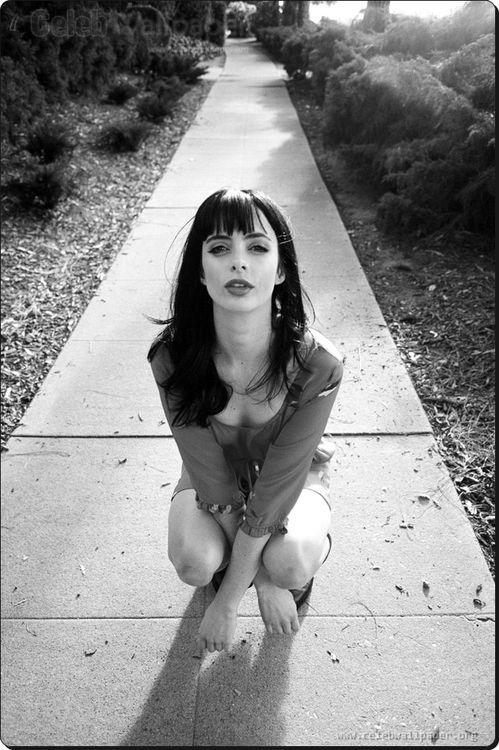What do you think is going on in this snapshot? In this black and white photo, the actress Krysten Ritter is depicted in a deeply evocative and pensive moment. She is kneeling on a sidewalk, creating an immediacy and intimacy with the viewer. The contrasting play of her light-colored blouse against her dark pants adds a compelling visual interest. Notably, her intensely focused gaze and the way her hair frames her face convey a profound sense of purpose and determination. The unadorned sidewalk and the greenery in the background harmoniously complement this introspective portrait, making it not just an image but a narrative of raw, emotional depth. 